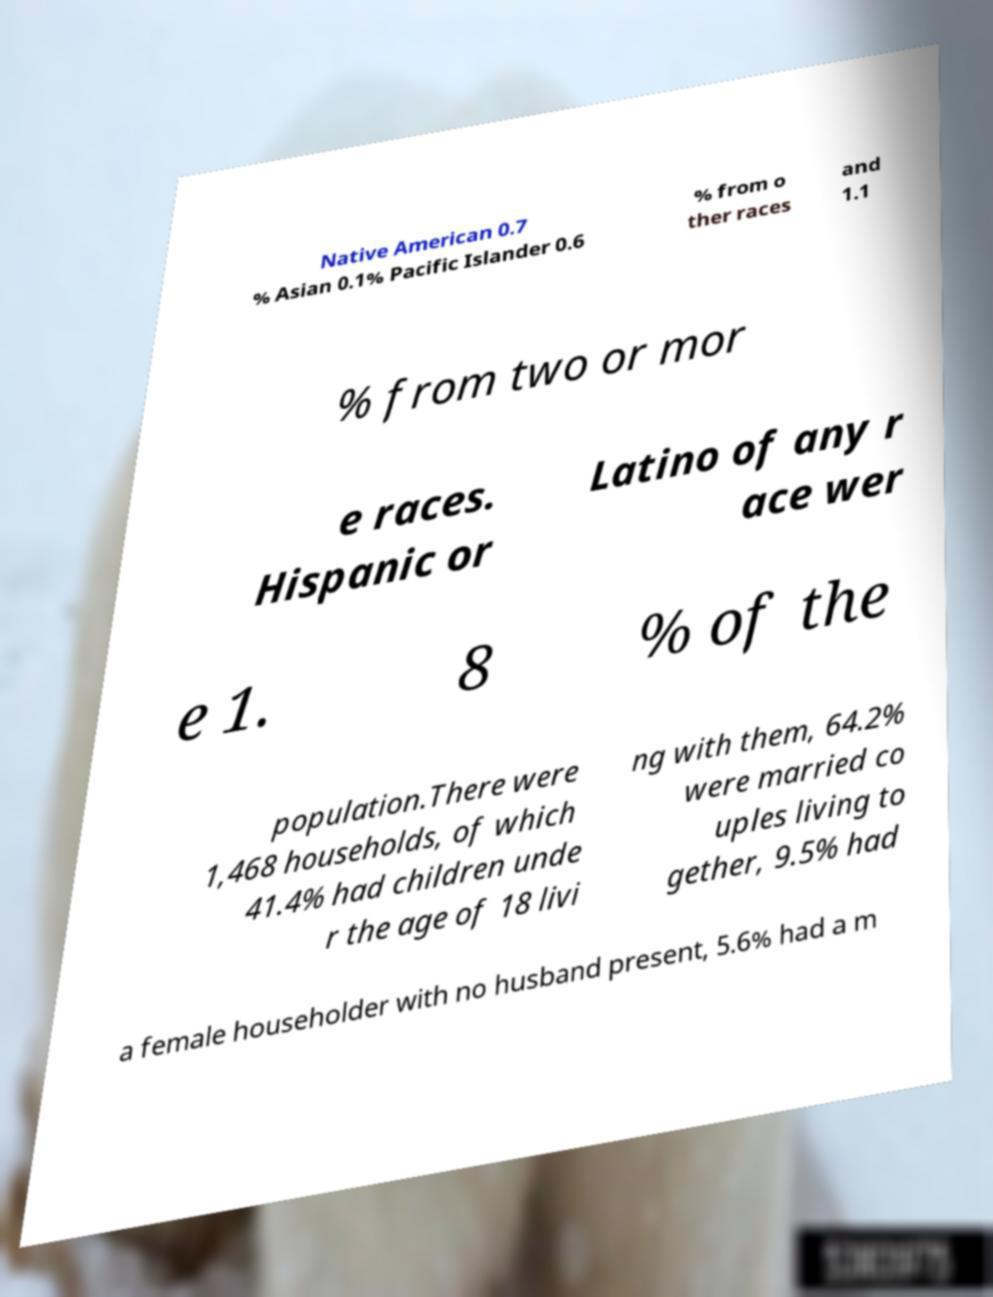Please read and relay the text visible in this image. What does it say? Native American 0.7 % Asian 0.1% Pacific Islander 0.6 % from o ther races and 1.1 % from two or mor e races. Hispanic or Latino of any r ace wer e 1. 8 % of the population.There were 1,468 households, of which 41.4% had children unde r the age of 18 livi ng with them, 64.2% were married co uples living to gether, 9.5% had a female householder with no husband present, 5.6% had a m 